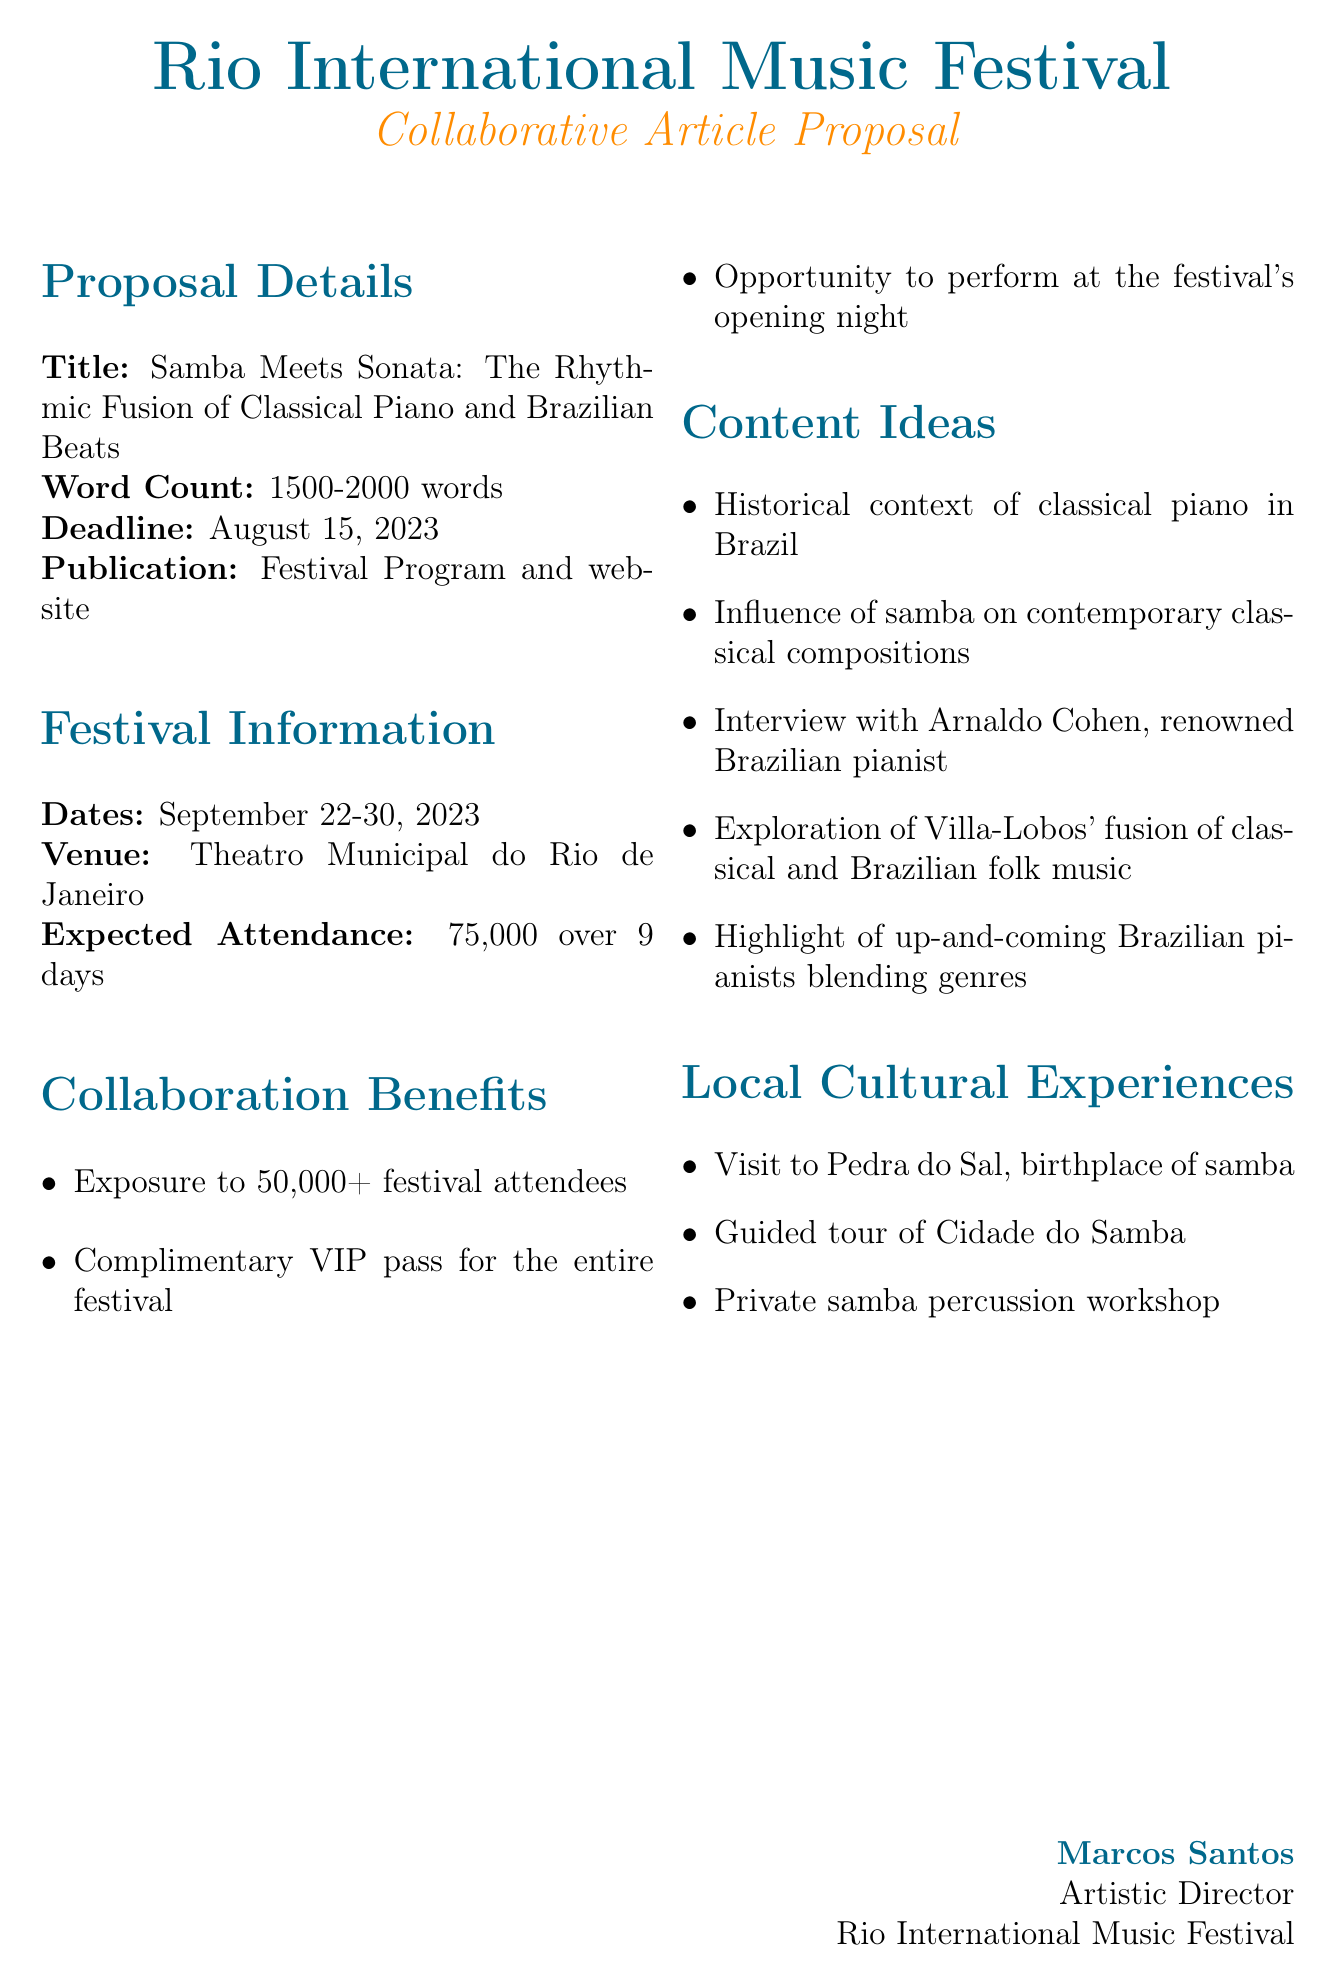What is the title of the article proposal? The title is explicitly stated in the proposal details section of the document.
Answer: Samba Meets Sonata: The Rhythmic Fusion of Classical Piano and Brazilian Beats What is the word count range for the article? The document specifies the word count required for the article proposal.
Answer: 1500-2000 words When is the deadline for the article submission? The document provides a specific date for when the article needs to be submitted.
Answer: August 15, 2023 Who is the Artistic Director of the Rio International Music Festival? The sender's information clearly identifies the person's position and name.
Answer: Marcos Santos What is the expected attendance for the festival? This information is provided in the festival information section, indicating the number of attendees.
Answer: 75,000 over 9 days What are two local cultural experiences mentioned in the proposal? The document lists several cultural experiences that are local to Rio de Janeiro.
Answer: Visit to Pedra do Sal, Guided tour of Cidade do Samba What opportunity is offered to the travel writer for the opening night of the festival? The collaboration benefits section outlines opportunities available to the recipient.
Answer: Opportunity to perform at the festival's opening night What is the venue for the Rio International Music Festival? The venue is specified in the festival information section of the proposal.
Answer: Theatro Municipal do Rio de Janeiro Which renowned pianist is suggested for an interview in the content ideas? The document mentions a specific pianist in the content ideas that can provide valuable insights.
Answer: Arnaldo Cohen 